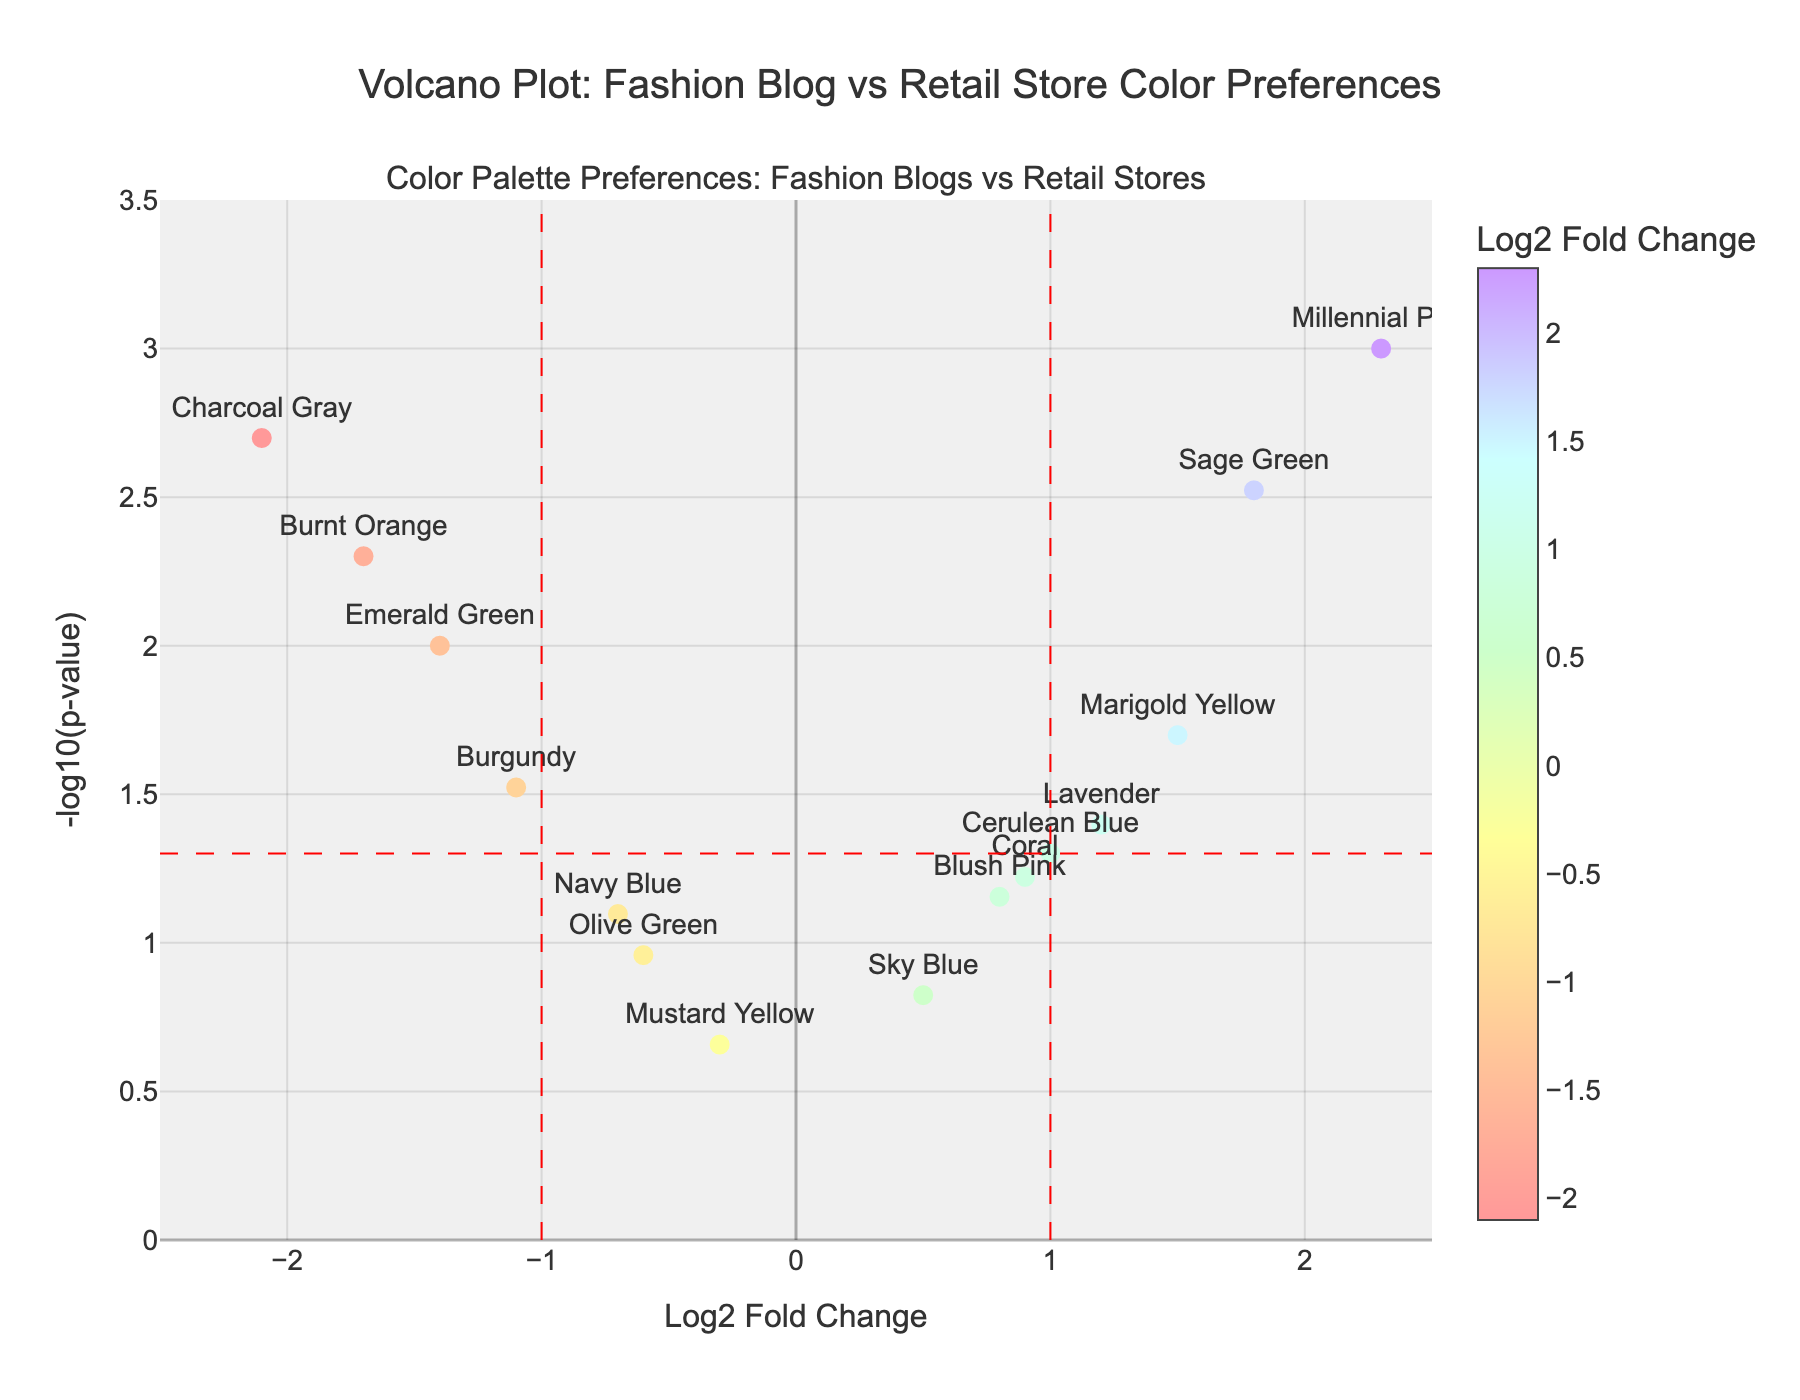What is the title of the plot? The title of a plot is usually found at the top center of the figure. In this case, the plot's title is clearly stated as "Volcano Plot: Fashion Blog vs Retail Store Color Preferences".
Answer: Volcano Plot: Fashion Blog vs Retail Store Color Preferences How many colors are there in total in the plot? You can count the number of unique data points (colors) displayed as scatter points. By observing the marked points with corresponding color names, there are 15 different colors.
Answer: 15 Which color has the highest Log2 Fold Change (LogFC)? The highest LogFC is the farthest point to the right on the x-axis. "Millennial Pink" has a LogFC of 2.3, making it the highest.
Answer: Millennial Pink Which three colors have the lowest p-values? P-values are represented on the y-axis as -log10(p-value); the higher on the y-axis, the lower the p-value. The three highest points are "Millennial Pink", "Charcoal Gray", and "Sage Green", corresponding to the lowest p-values.
Answer: Millennial Pink, Charcoal Gray, Sage Green Are there any colors that lie outside the marked vertical red dashed lines? Vertical red dashed lines are at LogFC = -1 and LogFC = 1. Colors outside are those with LogFC less than -1 or greater than 1. Colors include "Emerald Green", "Burnt Orange", "Charcoal Gray", "Millennial Pink", "Sage Green", "Marigold Yellow", "Lavender", and "Cerulean Blue".
Answer: Yes Which color has a Log2 Fold Change (LogFC) closest to zero? Look for the point nearest to the vertical line at LogFC = 0. "Mustard Yellow" has a LogFC of -0.3, which is the closest.
Answer: Mustard Yellow Can you identify the most significantly upregulated color based on the plot? Upregulated indicates a positive LogFC. The most significant has the highest point on the y-axis with LogFC > 0. "Millennial Pink" is the highest point with a LogFC of 2.3 and a very low p-value.
Answer: Millennial Pink What is the range of -log10(p-value) represented in the plot? The y-axis shows -log10(p-value), ranging from 0 to 3.5 based on axis markings and data extent depicted.
Answer: 0 to 3.5 Which color has the least significant p-value? The least significant p-value corresponds to the lowest point on the y-axis in -log10(p-value). "Mustard Yellow" at p-value 0.22 is the lowest on the y-axis.
Answer: Mustard Yellow 